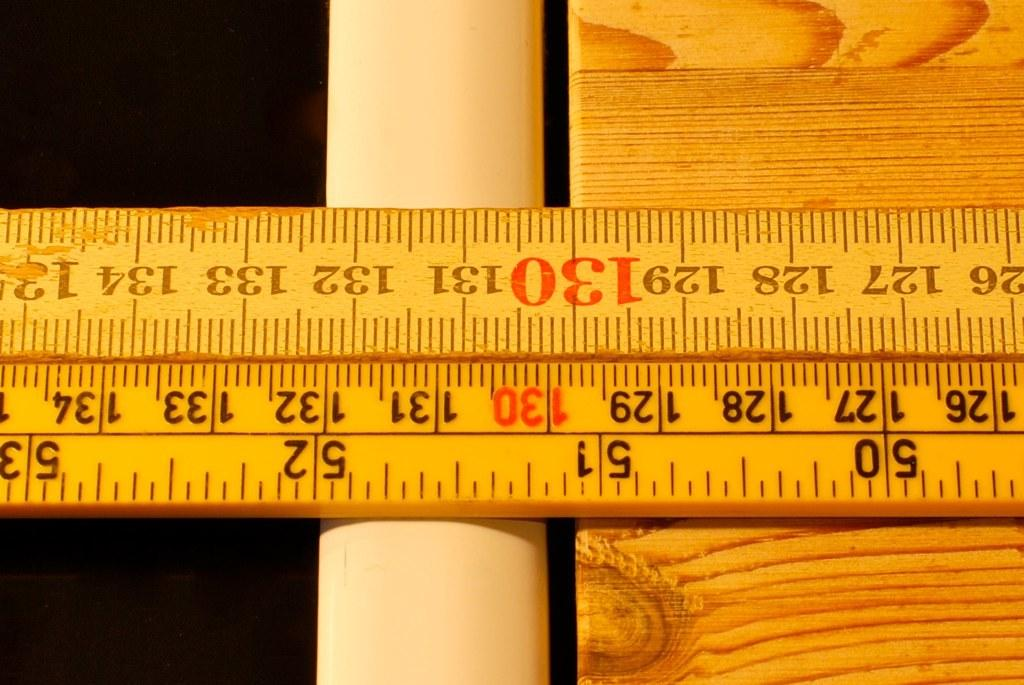<image>
Create a compact narrative representing the image presented. A ruler designates where 130cm is on this bit of wood. 